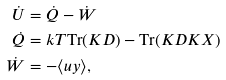Convert formula to latex. <formula><loc_0><loc_0><loc_500><loc_500>\dot { U } & = \dot { Q } - \dot { W } \\ \dot { Q } & = k T \text {Tr} ( K D ) - \text {Tr} ( K D K X ) \\ \dot { W } & = - \langle u y \rangle ,</formula> 